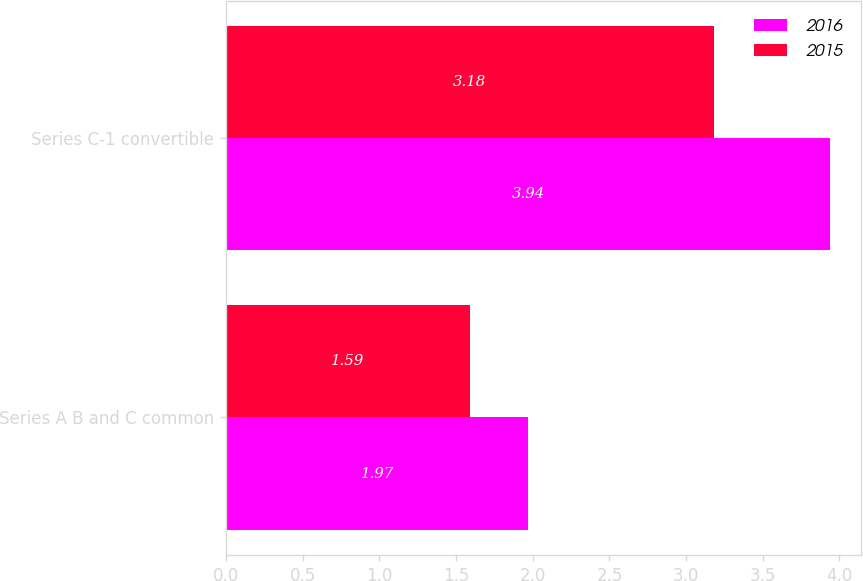<chart> <loc_0><loc_0><loc_500><loc_500><stacked_bar_chart><ecel><fcel>Series A B and C common<fcel>Series C-1 convertible<nl><fcel>2016<fcel>1.97<fcel>3.94<nl><fcel>2015<fcel>1.59<fcel>3.18<nl></chart> 